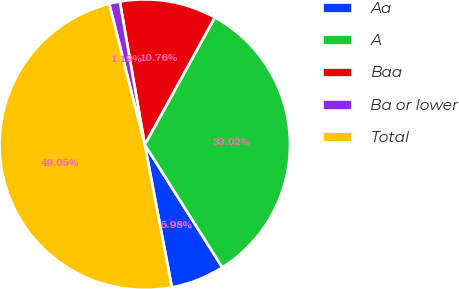Convert chart to OTSL. <chart><loc_0><loc_0><loc_500><loc_500><pie_chart><fcel>Aa<fcel>A<fcel>Baa<fcel>Ba or lower<fcel>Total<nl><fcel>5.98%<fcel>33.02%<fcel>10.76%<fcel>1.19%<fcel>49.05%<nl></chart> 